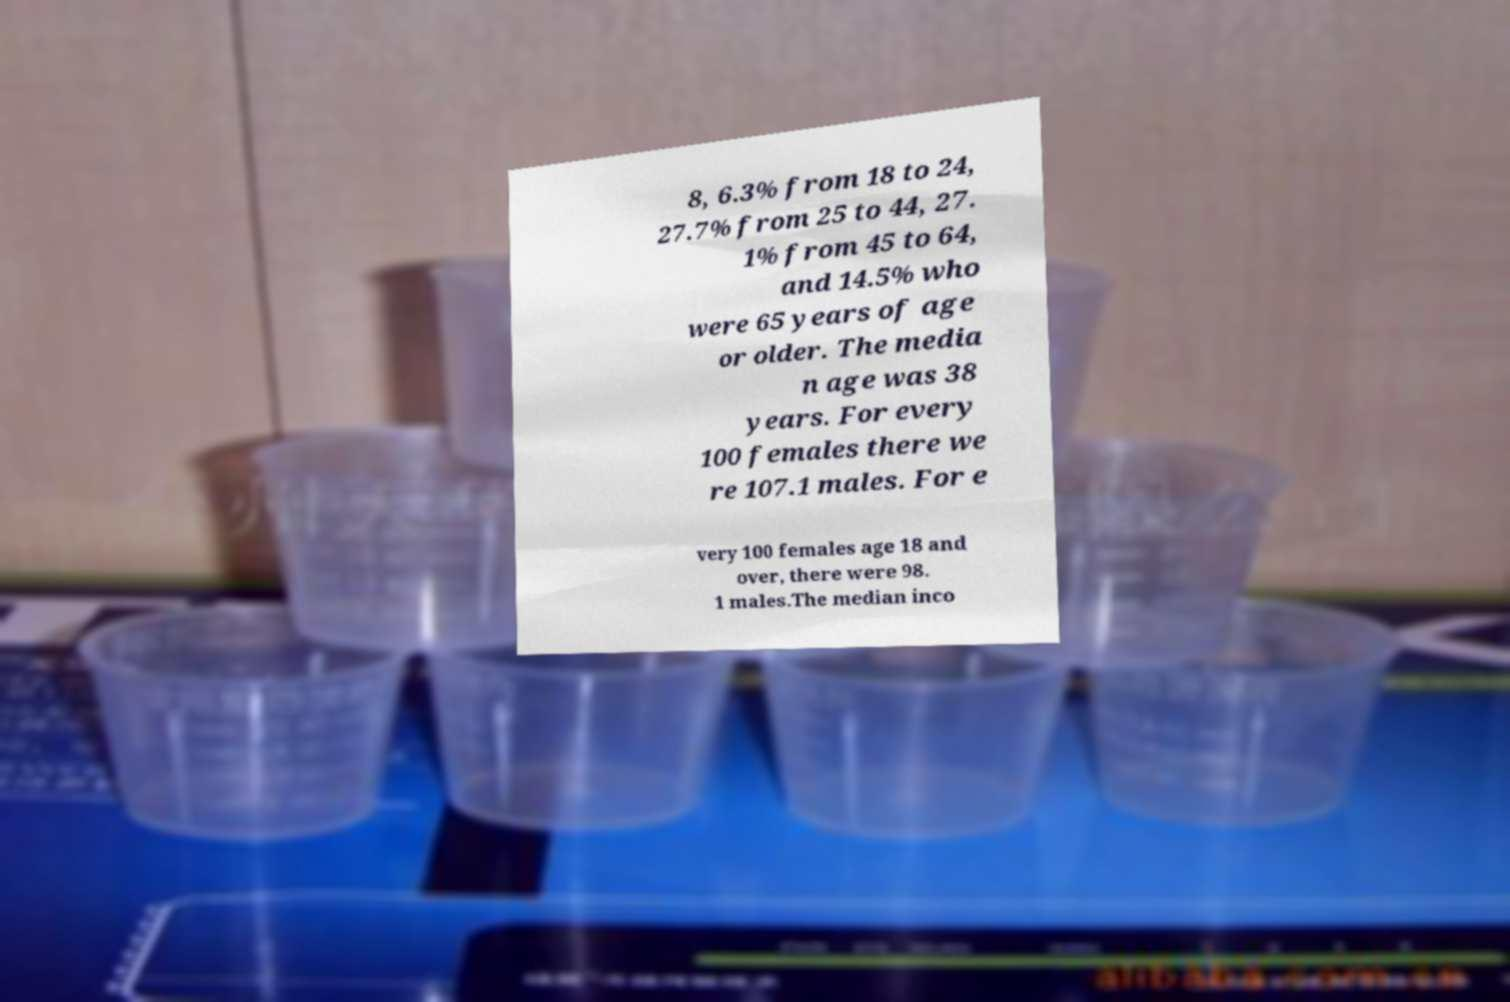Please identify and transcribe the text found in this image. 8, 6.3% from 18 to 24, 27.7% from 25 to 44, 27. 1% from 45 to 64, and 14.5% who were 65 years of age or older. The media n age was 38 years. For every 100 females there we re 107.1 males. For e very 100 females age 18 and over, there were 98. 1 males.The median inco 